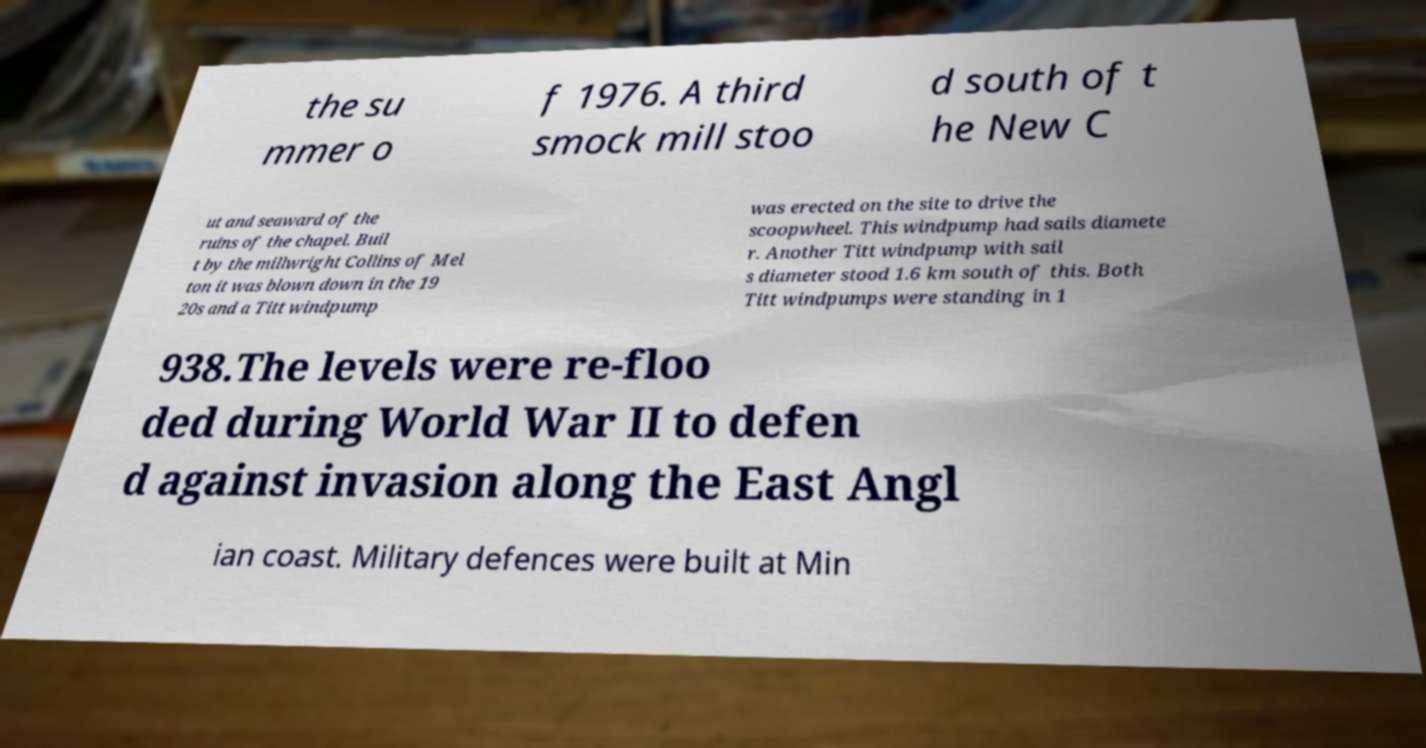Please identify and transcribe the text found in this image. the su mmer o f 1976. A third smock mill stoo d south of t he New C ut and seaward of the ruins of the chapel. Buil t by the millwright Collins of Mel ton it was blown down in the 19 20s and a Titt windpump was erected on the site to drive the scoopwheel. This windpump had sails diamete r. Another Titt windpump with sail s diameter stood 1.6 km south of this. Both Titt windpumps were standing in 1 938.The levels were re-floo ded during World War II to defen d against invasion along the East Angl ian coast. Military defences were built at Min 